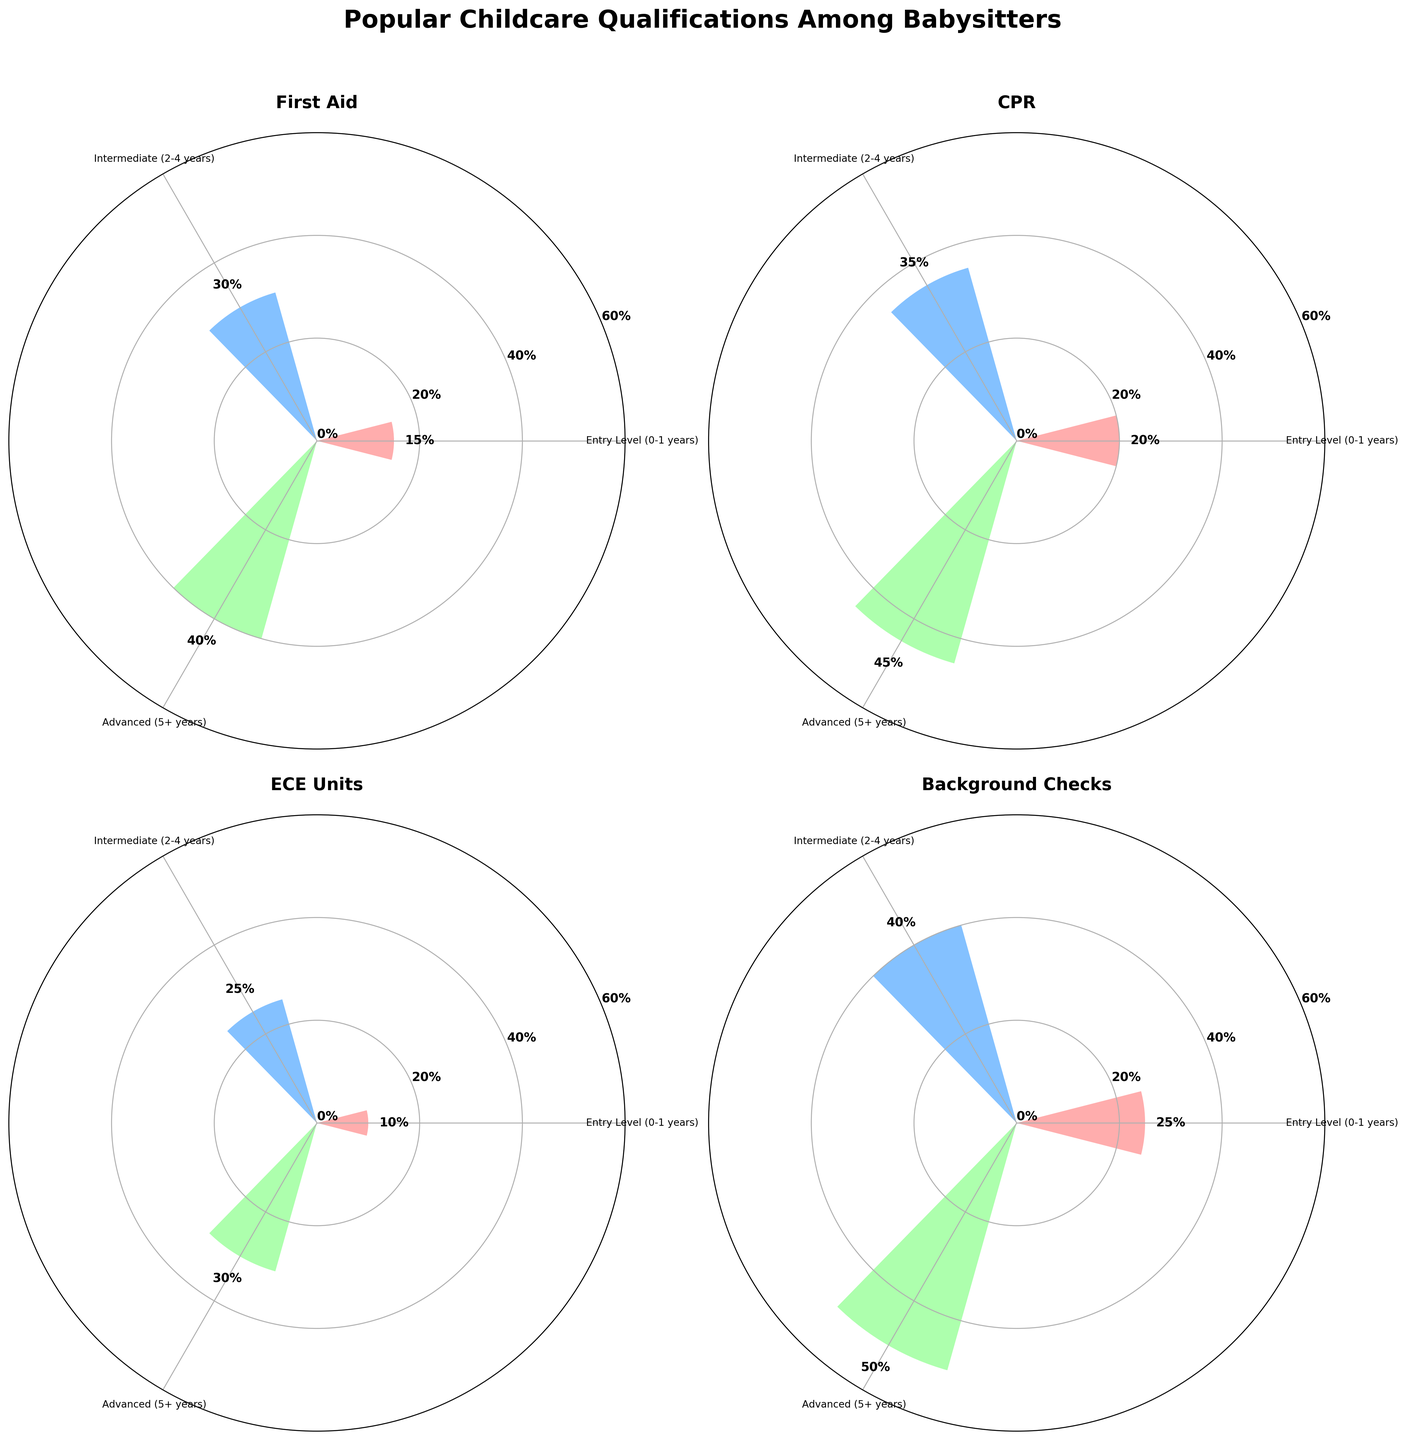what are the qualifications shown in the figure? The qualifications are the categories under which babysitters' percentages are measured. By examining the titles of each subplot, we see the qualifications: First Aid, CPR, ECE Units, and Background Checks.
Answer: First Aid, CPR, ECE Units, Background Checks How is the percentage for First Aid qualification distributed among different experience levels? Looking at the corresponding subplot, the percentages for Entry Level (0-1 years), Intermediate (2-4 years), and Advanced (5+ years) are displayed on the bars. The values are labeled, showing 15%, 30%, and 40% respectively.
Answer: 15% for Entry Level, 30% for Intermediate, 40% for Advanced Which qualification has the highest percentage for Entry Level (0-1 years)? By examining the Entry Level bars across all subplots, we see the highest percentage among them, which is labeled on the Background Checks bar as 25%.
Answer: Background Checks What is the difference in the percentage of Advanced level CPR qualification compared to Intermediate level ECE Units qualification? The subplot for CPR shows that Advanced level has a percentage of 45%, while the subplot for ECE Units shows that Intermediate level has 25%. The difference between them is 45% - 25% = 20%.
Answer: 20% Which experience level has the highest percentage for Background Checks qualification? Observing the chart for Background Checks, the Entry Level (25%), Intermediate (40%), and Advanced (50%) are the values, with Advanced standing out as the highest.
Answer: Advanced Among the ECE Units qualification, which experience level has the lowest percentage? Looking at the ECE Units subplot, Entry Level has 10%, Intermediate has 25%, and Advanced has 30%. The lowest among these is Entry Level.
Answer: Entry Level What's the average percentage for each qualification at the Advanced experience level? To find the average, sum the percentages for Advanced across all qualifications: First Aid (40%), CPR (45%), ECE Units (30%), and Background Checks (50%). The sum is 40 + 45 + 30 + 50 = 165. Dividing by 4 (number of qualifications) gives 165 / 4 = 41.25%.
Answer: 41.25% How do the percentages compare between Entry Level for CPR and ECE Units? From the respective subplots, CPR at Entry Level is 20%, while ECE Units at Entry Level is 10%. CPR has a higher percentage than ECE Units at this experience level.
Answer: CPR is higher What is the total percentage for Intermediate levels across all qualifications? Sum the percentages for Intermediate levels from each qualification: First Aid (30%), CPR (35%), ECE Units (25%), and Background Checks (40%). The total is 30 + 35 + 25 + 40 = 130%.
Answer: 130% Which experience level shows the greatest variation in percentage across different qualifications? Calculating the differences for each experience level: Entry Level (First Aid 15%, CPR 20%, ECE Units 10%, Background Checks 25%) varies between 10% and 25%, Intermediate (First Aid 30%, CPR 35%, ECE Units 25%, Background Checks 40%) varies between 25% and 40%, and Advanced (First Aid 40%, CPR 45%, ECE Units 30%, Background Checks 50%) varies between 30% and 50%. Advanced Level has the greatest range (20%).
Answer: Advanced 